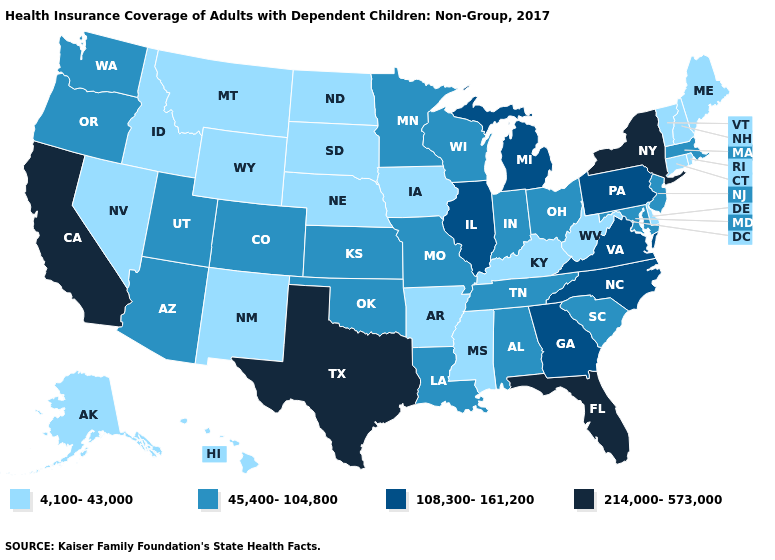What is the value of Utah?
Give a very brief answer. 45,400-104,800. What is the value of Missouri?
Give a very brief answer. 45,400-104,800. Name the states that have a value in the range 4,100-43,000?
Short answer required. Alaska, Arkansas, Connecticut, Delaware, Hawaii, Idaho, Iowa, Kentucky, Maine, Mississippi, Montana, Nebraska, Nevada, New Hampshire, New Mexico, North Dakota, Rhode Island, South Dakota, Vermont, West Virginia, Wyoming. Name the states that have a value in the range 45,400-104,800?
Answer briefly. Alabama, Arizona, Colorado, Indiana, Kansas, Louisiana, Maryland, Massachusetts, Minnesota, Missouri, New Jersey, Ohio, Oklahoma, Oregon, South Carolina, Tennessee, Utah, Washington, Wisconsin. Does Montana have a lower value than South Carolina?
Short answer required. Yes. Among the states that border Arkansas , does Mississippi have the lowest value?
Short answer required. Yes. What is the lowest value in the USA?
Concise answer only. 4,100-43,000. Among the states that border New York , does New Jersey have the lowest value?
Be succinct. No. Name the states that have a value in the range 4,100-43,000?
Answer briefly. Alaska, Arkansas, Connecticut, Delaware, Hawaii, Idaho, Iowa, Kentucky, Maine, Mississippi, Montana, Nebraska, Nevada, New Hampshire, New Mexico, North Dakota, Rhode Island, South Dakota, Vermont, West Virginia, Wyoming. Which states have the highest value in the USA?
Give a very brief answer. California, Florida, New York, Texas. What is the value of Kentucky?
Answer briefly. 4,100-43,000. Does Vermont have the same value as Hawaii?
Write a very short answer. Yes. Does Washington have a higher value than Arkansas?
Concise answer only. Yes. Does Indiana have the lowest value in the USA?
Quick response, please. No. Does Connecticut have the highest value in the USA?
Write a very short answer. No. 